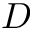<formula> <loc_0><loc_0><loc_500><loc_500>D</formula> 